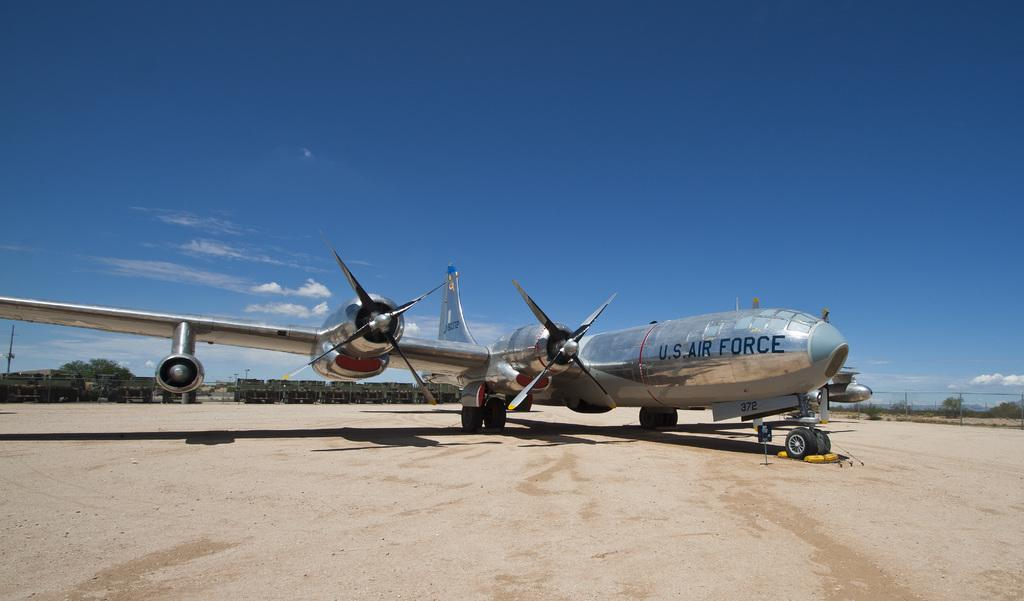<image>
Write a terse but informative summary of the picture. A large US Air Force prop airplane is parked on the dirt field. 